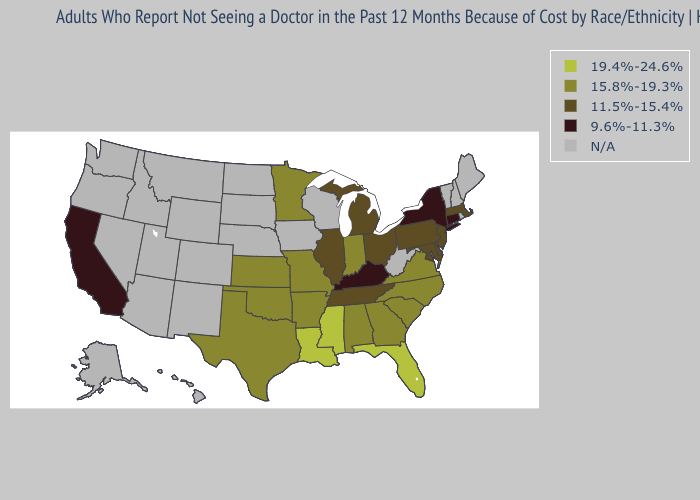Name the states that have a value in the range 19.4%-24.6%?
Keep it brief. Florida, Louisiana, Mississippi. Name the states that have a value in the range N/A?
Be succinct. Alaska, Arizona, Colorado, Hawaii, Idaho, Iowa, Maine, Montana, Nebraska, Nevada, New Hampshire, New Mexico, North Dakota, Oregon, Rhode Island, South Dakota, Utah, Vermont, Washington, West Virginia, Wisconsin, Wyoming. What is the value of Iowa?
Quick response, please. N/A. Name the states that have a value in the range 15.8%-19.3%?
Write a very short answer. Alabama, Arkansas, Georgia, Indiana, Kansas, Minnesota, Missouri, North Carolina, Oklahoma, South Carolina, Texas, Virginia. Name the states that have a value in the range 19.4%-24.6%?
Keep it brief. Florida, Louisiana, Mississippi. Name the states that have a value in the range N/A?
Write a very short answer. Alaska, Arizona, Colorado, Hawaii, Idaho, Iowa, Maine, Montana, Nebraska, Nevada, New Hampshire, New Mexico, North Dakota, Oregon, Rhode Island, South Dakota, Utah, Vermont, Washington, West Virginia, Wisconsin, Wyoming. What is the value of Illinois?
Give a very brief answer. 11.5%-15.4%. Does Kansas have the lowest value in the MidWest?
Keep it brief. No. Among the states that border Vermont , does New York have the lowest value?
Give a very brief answer. Yes. What is the value of Virginia?
Quick response, please. 15.8%-19.3%. Which states have the lowest value in the USA?
Be succinct. California, Connecticut, Kentucky, New York. Does the map have missing data?
Answer briefly. Yes. 